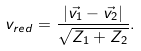Convert formula to latex. <formula><loc_0><loc_0><loc_500><loc_500>v _ { r e d } = \frac { | \vec { v _ { 1 } } - \vec { v _ { 2 } } | } { \sqrt { Z _ { 1 } + Z _ { 2 } } } .</formula> 